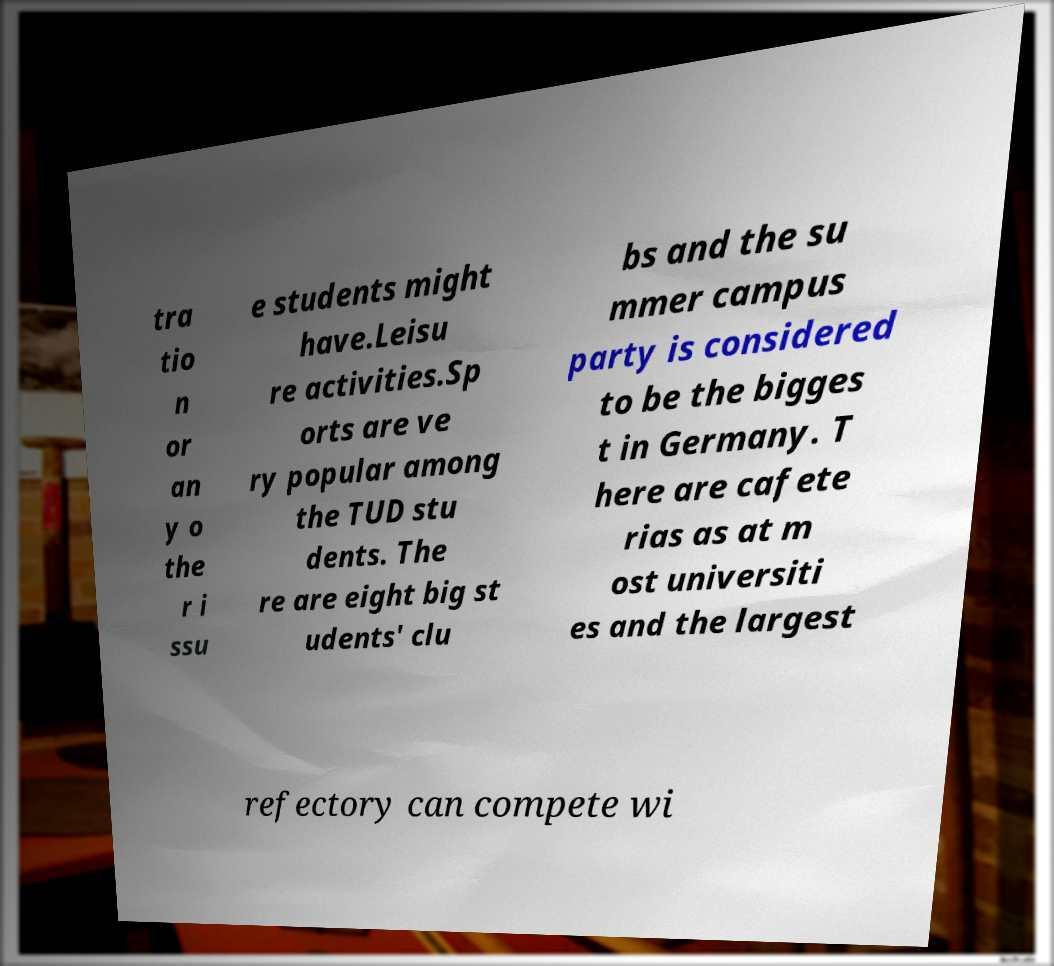Can you read and provide the text displayed in the image?This photo seems to have some interesting text. Can you extract and type it out for me? tra tio n or an y o the r i ssu e students might have.Leisu re activities.Sp orts are ve ry popular among the TUD stu dents. The re are eight big st udents' clu bs and the su mmer campus party is considered to be the bigges t in Germany. T here are cafete rias as at m ost universiti es and the largest refectory can compete wi 